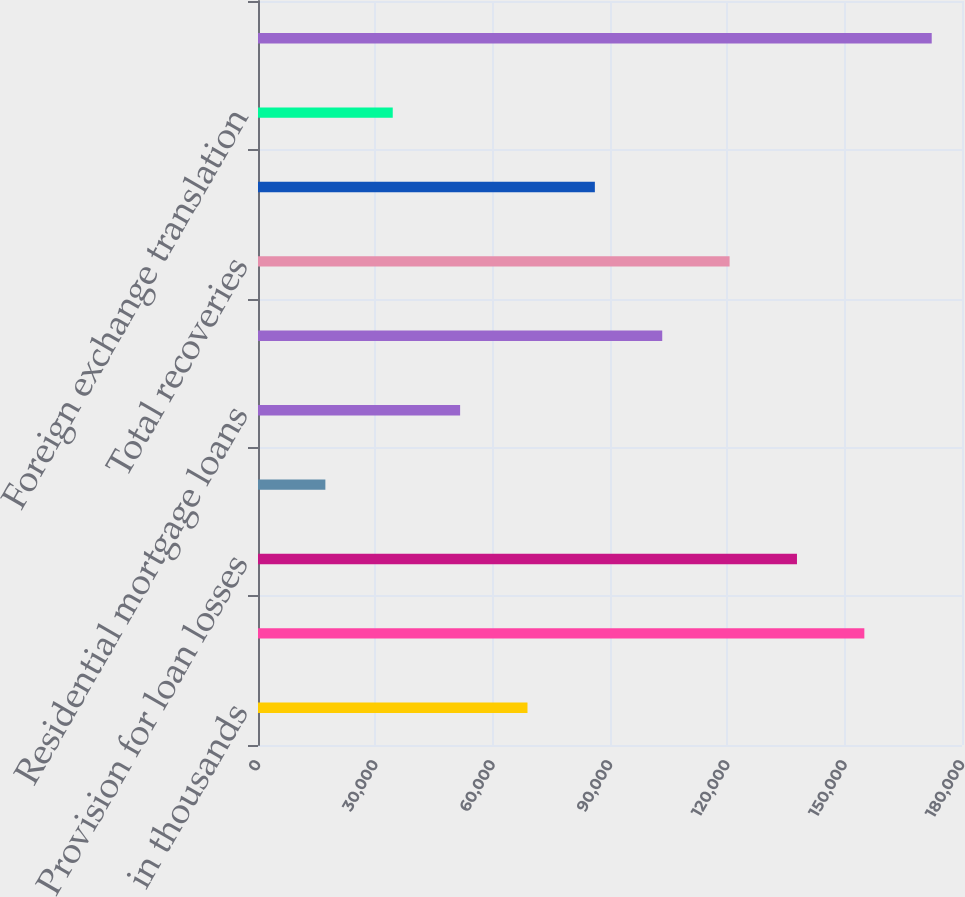Convert chart. <chart><loc_0><loc_0><loc_500><loc_500><bar_chart><fcel>in thousands<fcel>Allowance for loan losses<fcel>Provision for loan losses<fcel>C&I loans<fcel>Residential mortgage loans<fcel>Total charge-offs<fcel>Total recoveries<fcel>Net (charge-offs)/recoveries<fcel>Foreign exchange translation<fcel>Allowance for loan losses end<nl><fcel>68903.6<fcel>155031<fcel>137806<fcel>17226.9<fcel>51678<fcel>103355<fcel>120580<fcel>86129.2<fcel>34452.5<fcel>172257<nl></chart> 